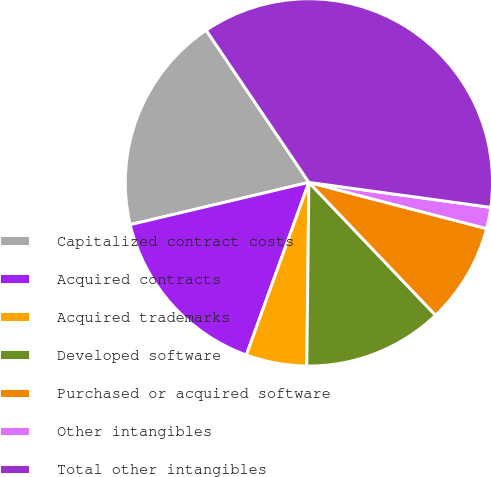Convert chart. <chart><loc_0><loc_0><loc_500><loc_500><pie_chart><fcel>Capitalized contract costs<fcel>Acquired contracts<fcel>Acquired trademarks<fcel>Developed software<fcel>Purchased or acquired software<fcel>Other intangibles<fcel>Total other intangibles<nl><fcel>19.25%<fcel>15.77%<fcel>5.35%<fcel>12.3%<fcel>8.83%<fcel>1.88%<fcel>36.62%<nl></chart> 